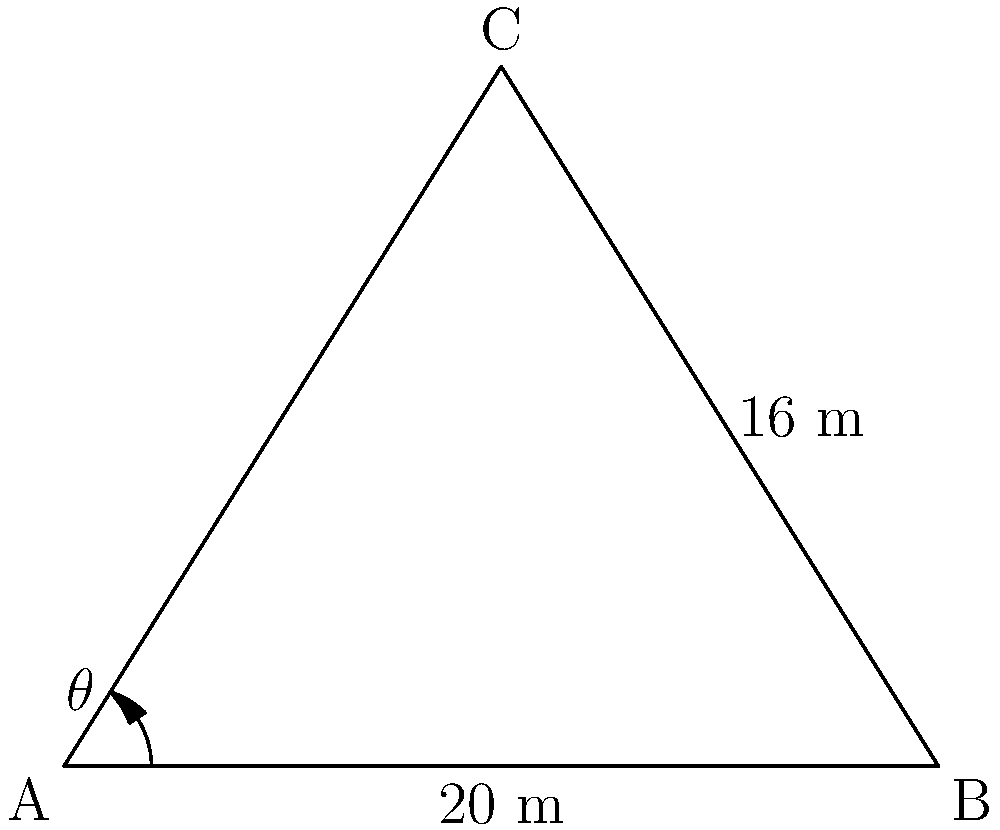As a real estate agent, you're showcasing a luxury apartment with panoramic windows. The windows span 20 meters along the floor and reach a height of 16 meters at the center, forming a triangular shape. What is the optimal viewing angle $\theta$ (in degrees) from the corner of the room to maximize the city skyline view? To find the optimal viewing angle $\theta$, we need to use trigonometry. Let's approach this step-by-step:

1) The apartment window forms a right-angled triangle. We know:
   - The base (floor length) is 20 meters
   - The height at the center is 16 meters

2) We can split this triangle into two equal right-angled triangles. For one of these triangles:
   - The base is 10 meters (half of 20)
   - The height is 16 meters

3) We can use the arctangent function to find the angle $\theta$:

   $$\tan(\theta) = \frac{\text{opposite}}{\text{adjacent}} = \frac{16}{10} = 1.6$$

4) To find $\theta$, we take the inverse tangent (arctangent):

   $$\theta = \arctan(1.6)$$

5) Using a calculator or trigonometric tables:

   $$\theta \approx 57.99^\circ$$

6) Rounding to the nearest degree:

   $$\theta \approx 58^\circ$$

This angle provides the optimal view of the city skyline through the panoramic windows.
Answer: $58^\circ$ 